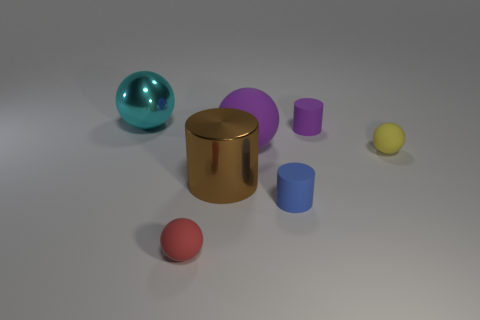Subtract all big cyan balls. How many balls are left? 3 Subtract 1 cylinders. How many cylinders are left? 2 Add 1 cyan objects. How many objects exist? 8 Subtract all blue balls. Subtract all cyan cylinders. How many balls are left? 4 Subtract all spheres. How many objects are left? 3 Subtract 1 purple cylinders. How many objects are left? 6 Subtract all tiny red rubber balls. Subtract all tiny blue matte cylinders. How many objects are left? 5 Add 1 yellow objects. How many yellow objects are left? 2 Add 6 tiny green metallic spheres. How many tiny green metallic spheres exist? 6 